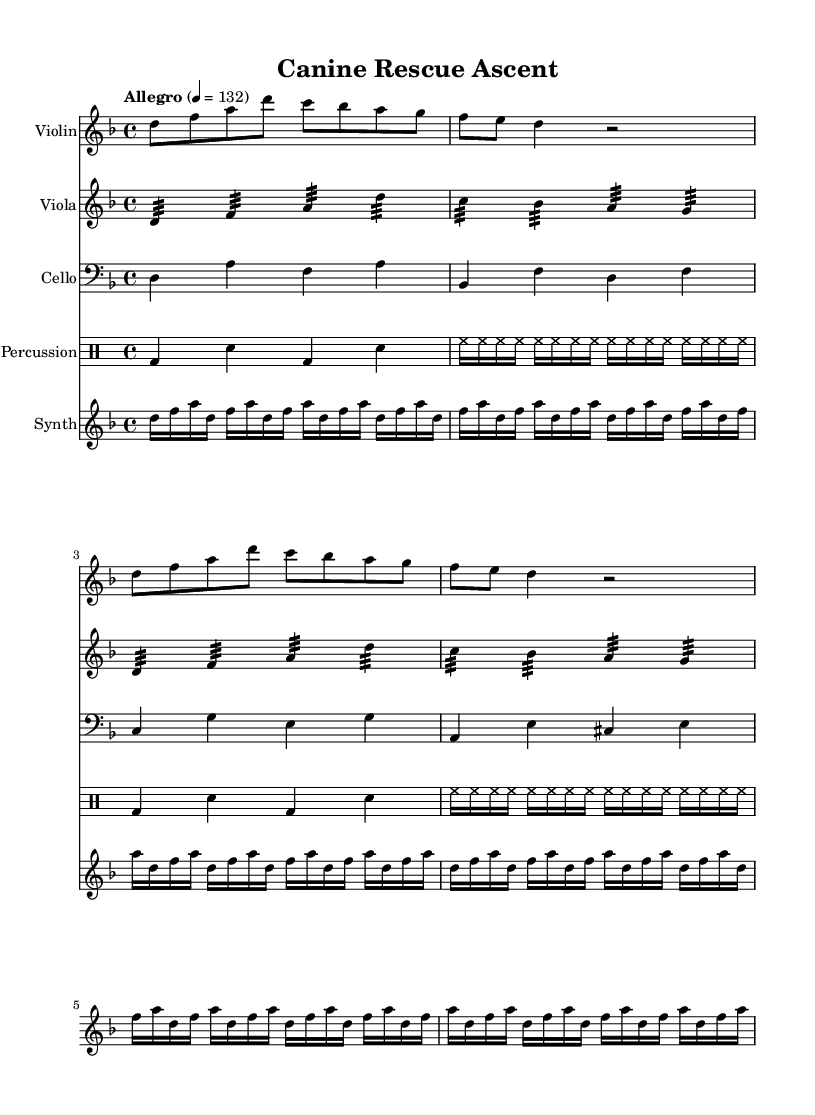What is the key signature of this music? The key signature is indicated at the beginning of the score, where the flat sign appears. In this case, there is one flat, which indicates the key of D minor.
Answer: D minor What is the time signature of this piece? The time signature is located next to the key signature at the start of the score. It is written as 4/4, meaning there are four beats in each measure and the quarter note receives one beat.
Answer: 4/4 What is the tempo marking of this piece? The tempo marking is found above the staff, stating "Allegro" followed by "4 = 132." This indicates the speed at which the piece should be performed.
Answer: Allegro How many measures are in the violin part? By counting the vertical lines (bar lines) in the violin part, we can determine the number of measures. There are seven bar lines, indicating the violin part is made up of eight measures.
Answer: 8 What type of ornamentation is used in the viola part? In the viola part, there is a use of tremolo indicated by the notation where the notes are marked with a small line. This technique creates a sense of tension throughout the piece.
Answer: Tremolo What pattern does the percussion part mainly feature? The percussion part consists of a repeating rhythm pattern using bass drum and snare drum. By analyzing the notation, we can see the indicated pattern is consistent throughout the excerpt.
Answer: Bass and snare rhythm What musical effect do the synthesizer arpeggios create in this piece? The synthesizer part has repeating arpeggiated notes, where the notes are played in succession rather than simultaneously. This technique contributes to a modern, uplifting feel typical in soundtracks, enhancing the thrilling aspect of the music.
Answer: Arpeggios 